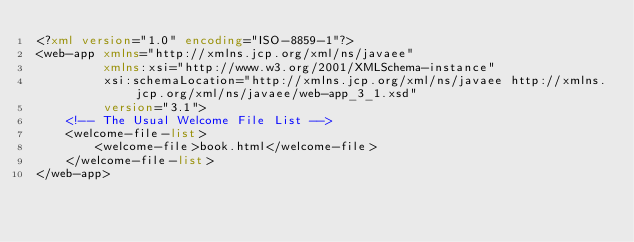<code> <loc_0><loc_0><loc_500><loc_500><_XML_><?xml version="1.0" encoding="ISO-8859-1"?>
<web-app xmlns="http://xmlns.jcp.org/xml/ns/javaee"
         xmlns:xsi="http://www.w3.org/2001/XMLSchema-instance"
         xsi:schemaLocation="http://xmlns.jcp.org/xml/ns/javaee http://xmlns.jcp.org/xml/ns/javaee/web-app_3_1.xsd"
         version="3.1">
    <!-- The Usual Welcome File List -->
    <welcome-file-list>
        <welcome-file>book.html</welcome-file>
    </welcome-file-list>
</web-app>
</code> 